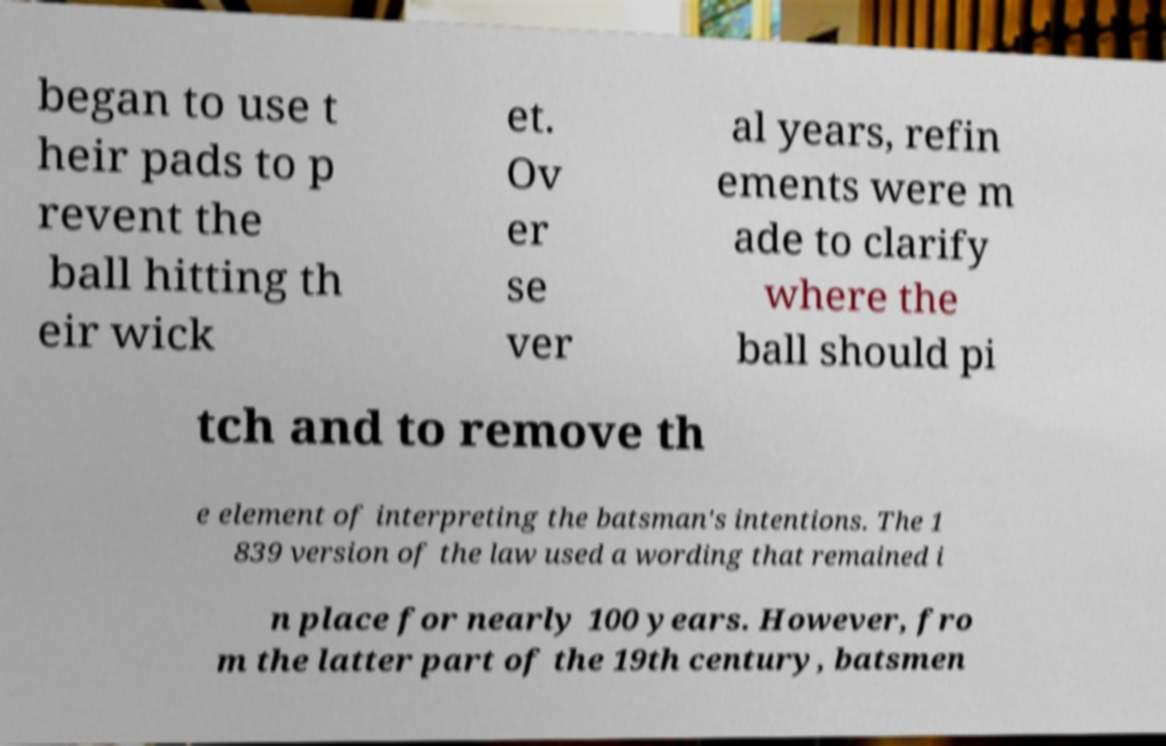Please identify and transcribe the text found in this image. began to use t heir pads to p revent the ball hitting th eir wick et. Ov er se ver al years, refin ements were m ade to clarify where the ball should pi tch and to remove th e element of interpreting the batsman's intentions. The 1 839 version of the law used a wording that remained i n place for nearly 100 years. However, fro m the latter part of the 19th century, batsmen 